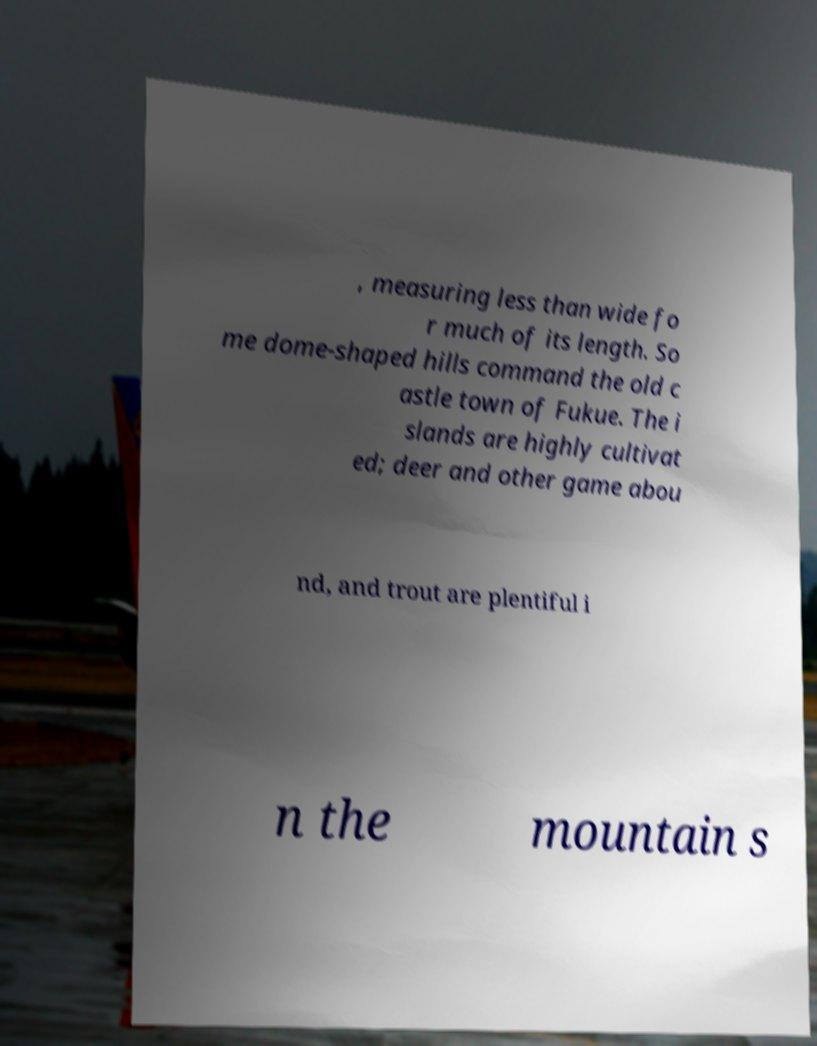Please identify and transcribe the text found in this image. , measuring less than wide fo r much of its length. So me dome-shaped hills command the old c astle town of Fukue. The i slands are highly cultivat ed; deer and other game abou nd, and trout are plentiful i n the mountain s 